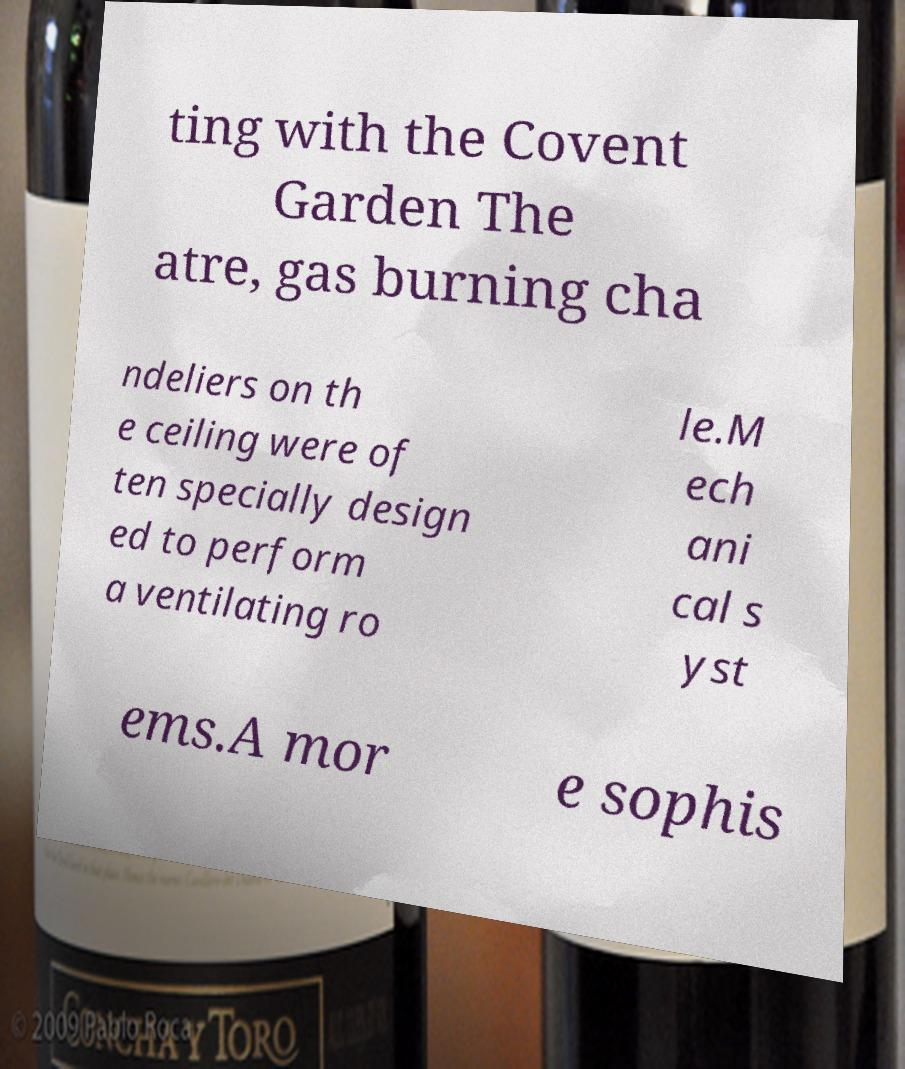There's text embedded in this image that I need extracted. Can you transcribe it verbatim? ting with the Covent Garden The atre, gas burning cha ndeliers on th e ceiling were of ten specially design ed to perform a ventilating ro le.M ech ani cal s yst ems.A mor e sophis 